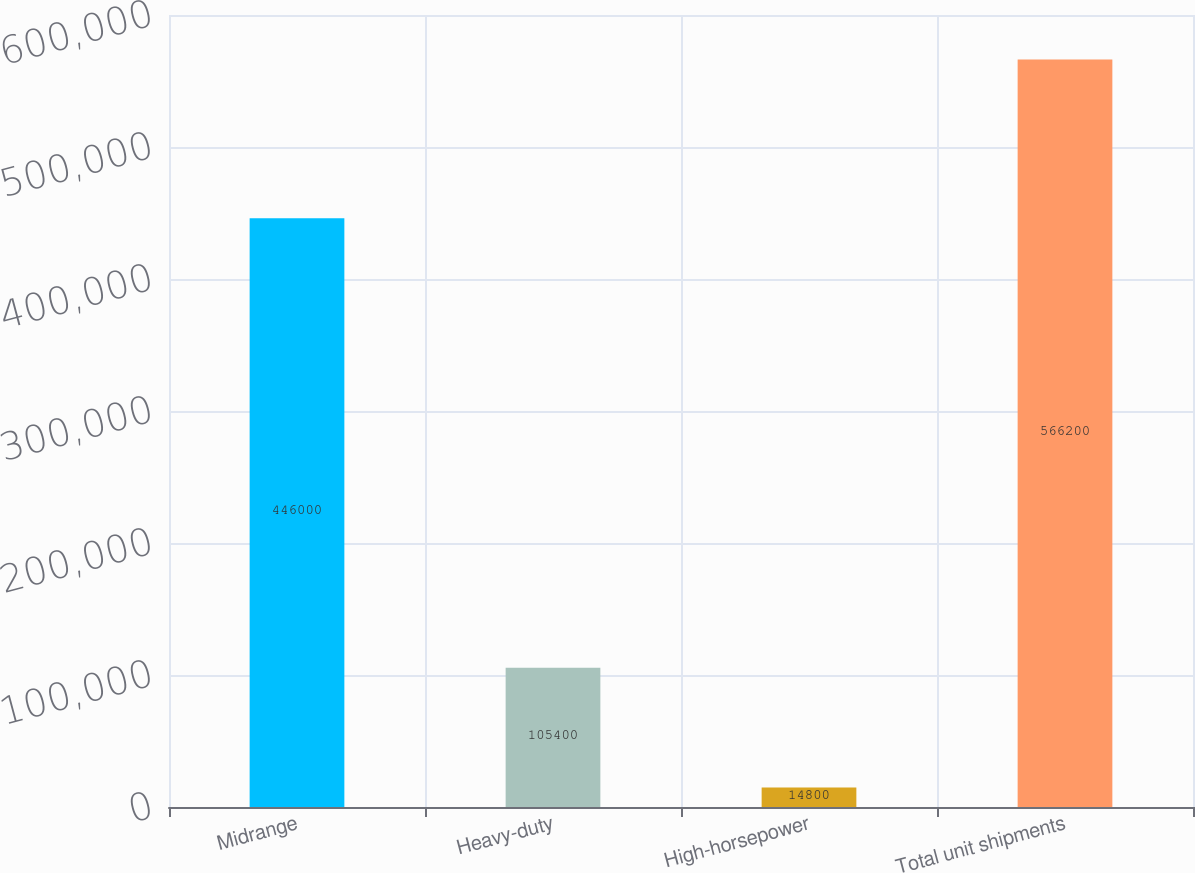Convert chart. <chart><loc_0><loc_0><loc_500><loc_500><bar_chart><fcel>Midrange<fcel>Heavy-duty<fcel>High-horsepower<fcel>Total unit shipments<nl><fcel>446000<fcel>105400<fcel>14800<fcel>566200<nl></chart> 